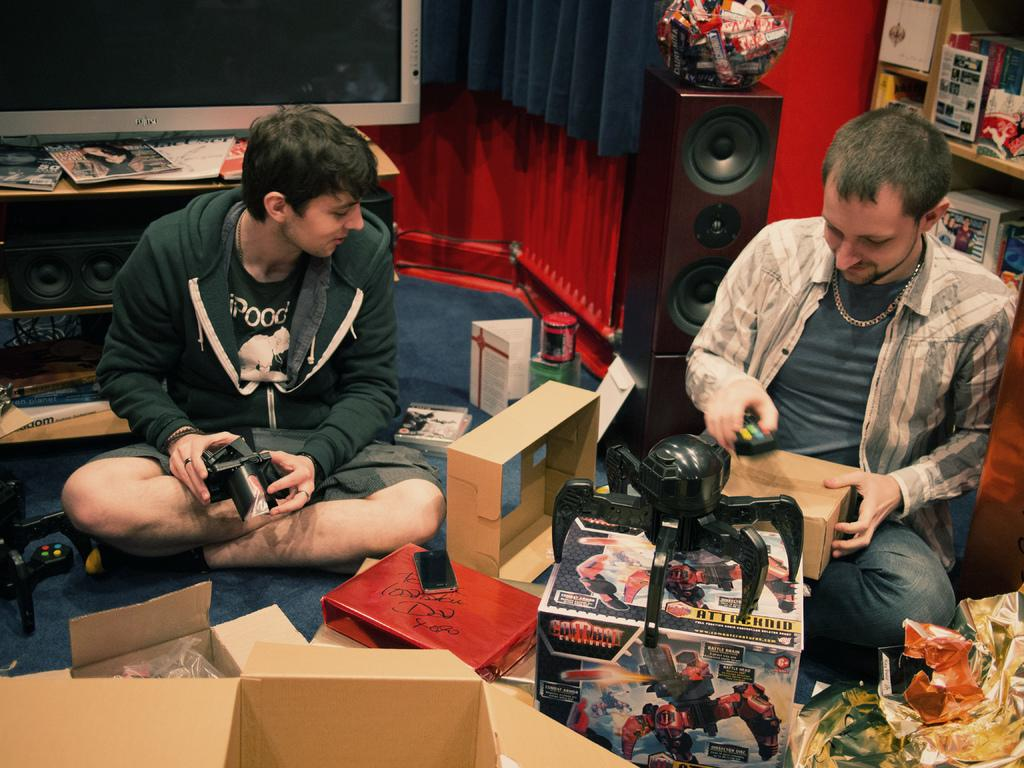How many people are sitting in the image? There are two men sitting in the image. What object can be seen near the men? There is a carton box in the image. What can be seen in the background of the image? There is a television in the background of the image. What type of audio equipment is visible in the image? There are speakers visible in the image. What type of grain is being harvested in the image? There is no grain or harvesting activity present in the image. What type of humor can be seen in the image? There is no humor or comedic element present in the image. 